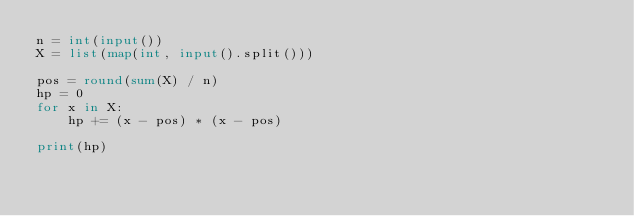<code> <loc_0><loc_0><loc_500><loc_500><_Python_>n = int(input())
X = list(map(int, input().split()))

pos = round(sum(X) / n)
hp = 0
for x in X:
    hp += (x - pos) * (x - pos)

print(hp)</code> 